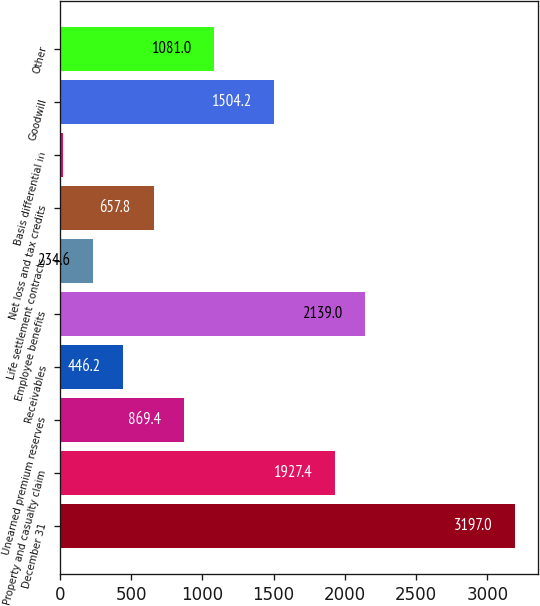Convert chart to OTSL. <chart><loc_0><loc_0><loc_500><loc_500><bar_chart><fcel>December 31<fcel>Property and casualty claim<fcel>Unearned premium reserves<fcel>Receivables<fcel>Employee benefits<fcel>Life settlement contracts<fcel>Net loss and tax credits<fcel>Basis differential in<fcel>Goodwill<fcel>Other<nl><fcel>3197<fcel>1927.4<fcel>869.4<fcel>446.2<fcel>2139<fcel>234.6<fcel>657.8<fcel>23<fcel>1504.2<fcel>1081<nl></chart> 